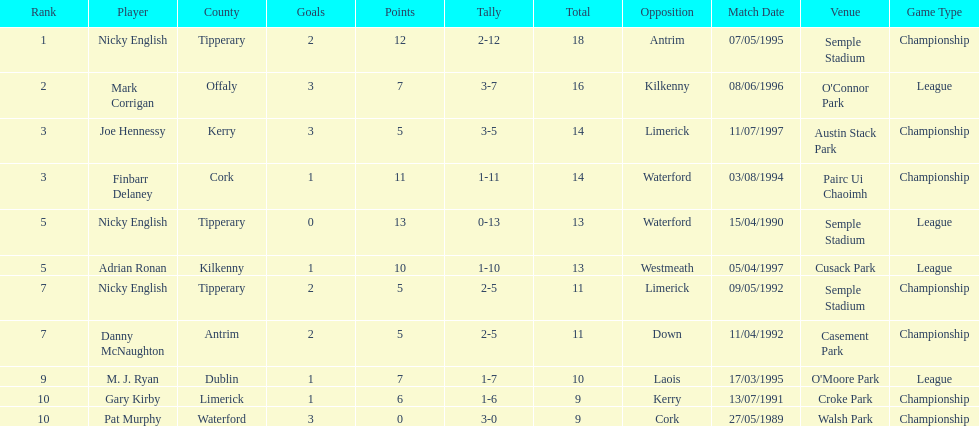What was the average of the totals of nicky english and mark corrigan? 17. 